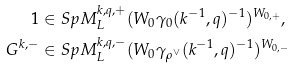Convert formula to latex. <formula><loc_0><loc_0><loc_500><loc_500>1 & \in S p M _ { L } ^ { k , q , + } ( W _ { 0 } \gamma _ { 0 } ( k ^ { - 1 } , q ) ^ { - 1 } ) ^ { W _ { 0 , + } } , \\ G ^ { k , - } & \in S p M _ { L } ^ { k , q , - } ( W _ { 0 } \gamma _ { \rho ^ { \vee } } ( k ^ { - 1 } , q ) ^ { - 1 } ) ^ { W _ { 0 , - } }</formula> 